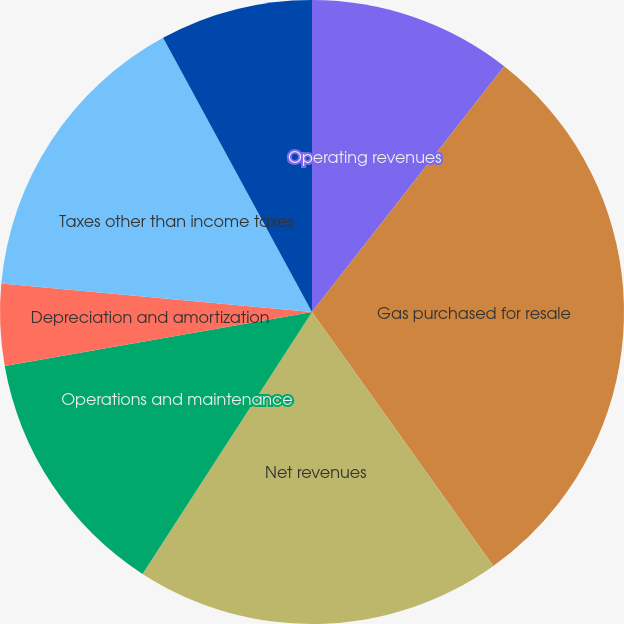Convert chart to OTSL. <chart><loc_0><loc_0><loc_500><loc_500><pie_chart><fcel>Operating revenues<fcel>Gas purchased for resale<fcel>Net revenues<fcel>Operations and maintenance<fcel>Depreciation and amortization<fcel>Taxes other than income taxes<fcel>Gas operating income<nl><fcel>10.56%<fcel>29.57%<fcel>19.01%<fcel>13.09%<fcel>4.22%<fcel>15.63%<fcel>7.92%<nl></chart> 